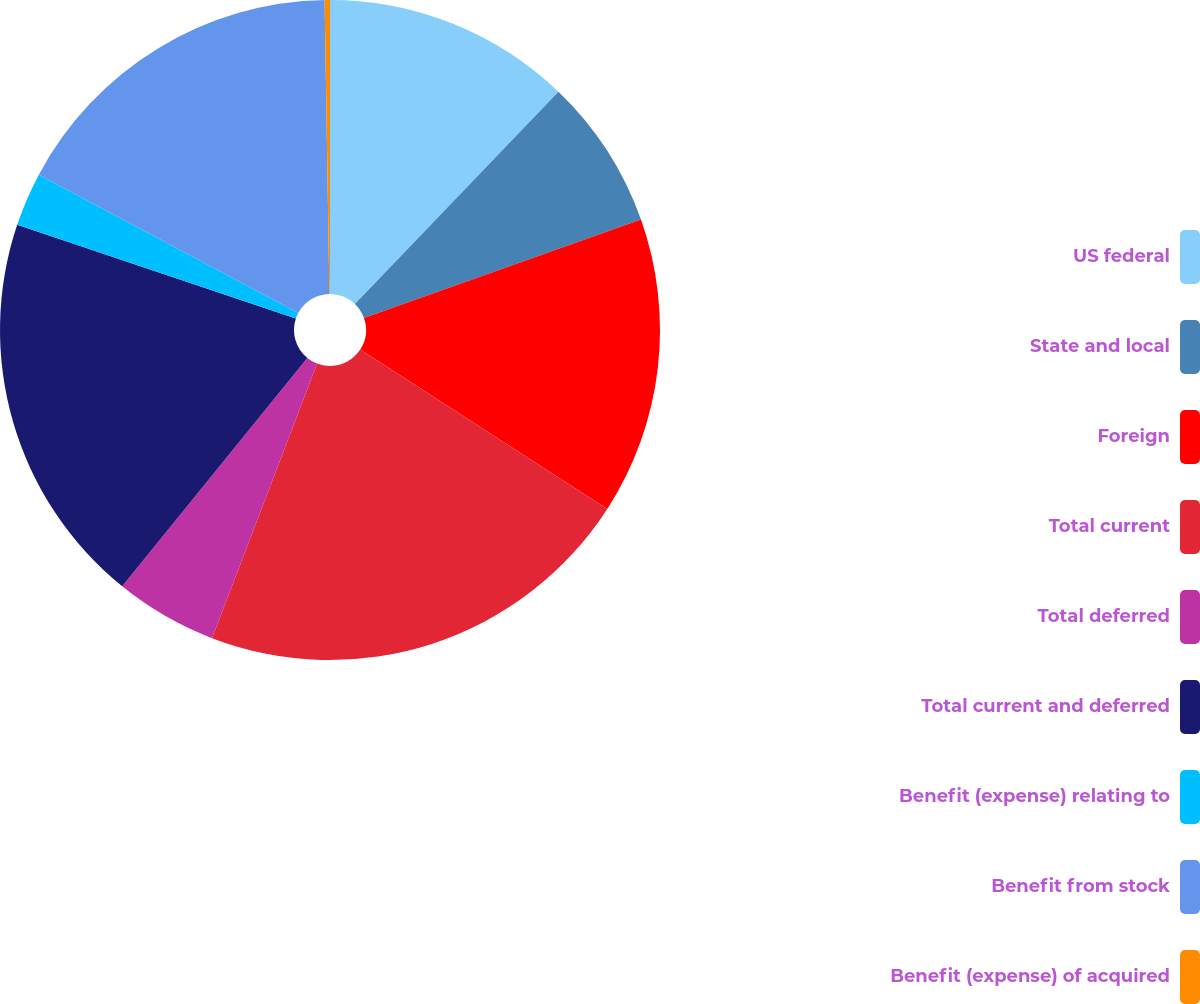Convert chart to OTSL. <chart><loc_0><loc_0><loc_500><loc_500><pie_chart><fcel>US federal<fcel>State and local<fcel>Foreign<fcel>Total current<fcel>Total deferred<fcel>Total current and deferred<fcel>Benefit (expense) relating to<fcel>Benefit from stock<fcel>Benefit (expense) of acquired<nl><fcel>12.17%<fcel>7.4%<fcel>14.55%<fcel>21.7%<fcel>5.02%<fcel>19.32%<fcel>2.64%<fcel>16.94%<fcel>0.26%<nl></chart> 